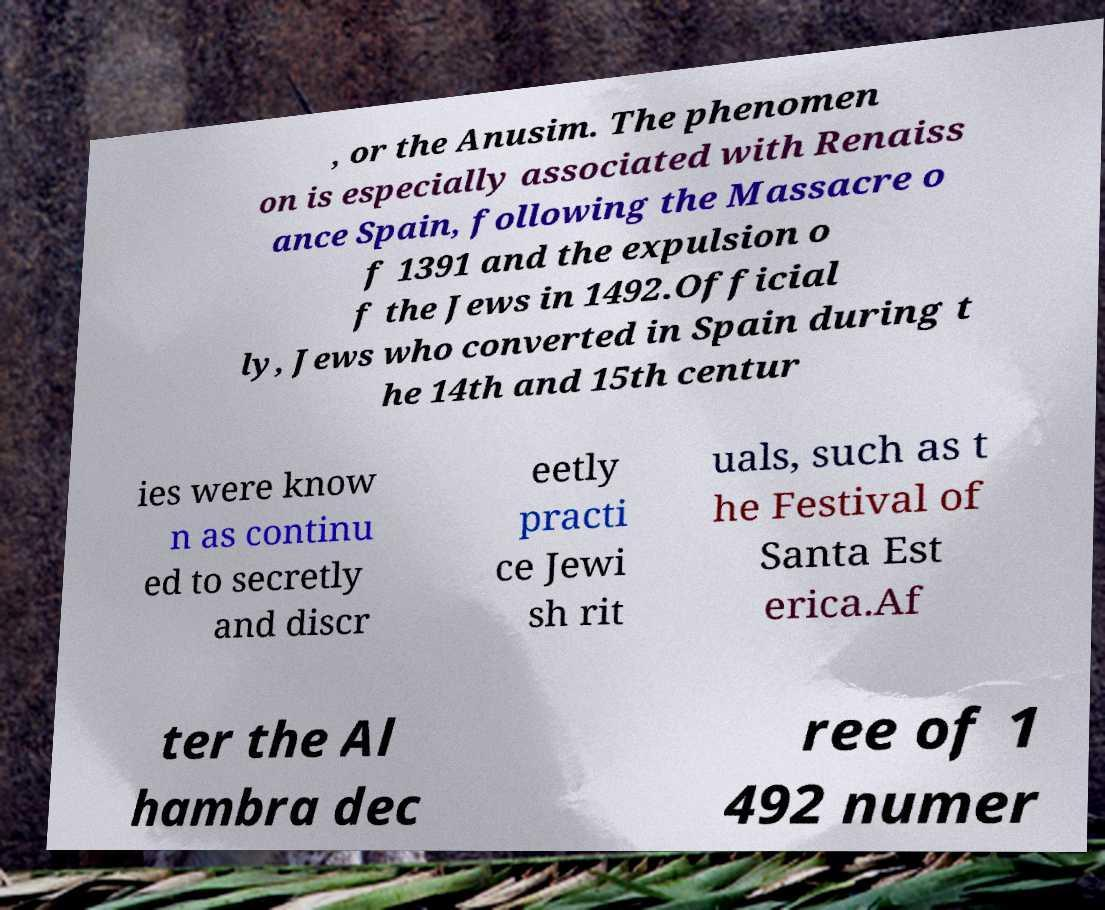For documentation purposes, I need the text within this image transcribed. Could you provide that? , or the Anusim. The phenomen on is especially associated with Renaiss ance Spain, following the Massacre o f 1391 and the expulsion o f the Jews in 1492.Official ly, Jews who converted in Spain during t he 14th and 15th centur ies were know n as continu ed to secretly and discr eetly practi ce Jewi sh rit uals, such as t he Festival of Santa Est erica.Af ter the Al hambra dec ree of 1 492 numer 